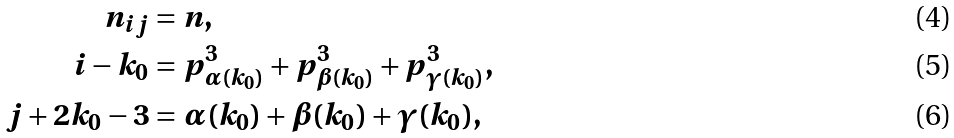<formula> <loc_0><loc_0><loc_500><loc_500>n _ { i j } & = n , \\ i - k _ { 0 } & = p ^ { 3 } _ { \alpha ( k _ { 0 } ) } + p ^ { 3 } _ { \beta ( k _ { 0 } ) } + p ^ { 3 } _ { \gamma ( k _ { 0 } ) } , \\ j + 2 k _ { 0 } - 3 & = \alpha ( k _ { 0 } ) + \beta ( k _ { 0 } ) + \gamma ( k _ { 0 } ) ,</formula> 